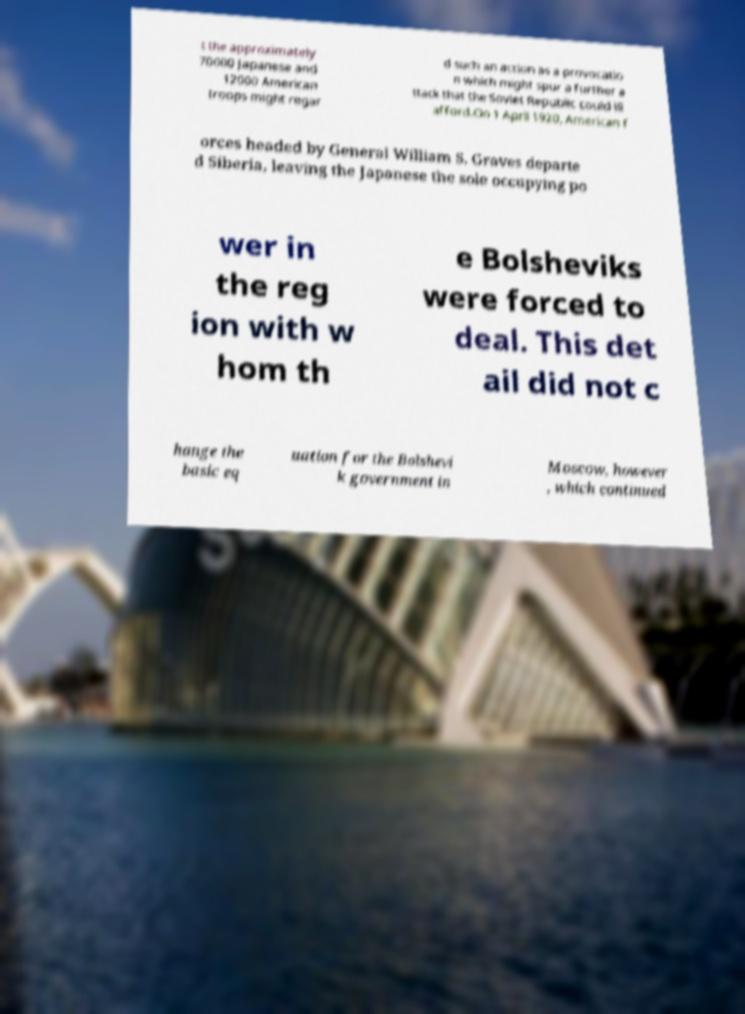For documentation purposes, I need the text within this image transcribed. Could you provide that? t the approximately 70000 Japanese and 12000 American troops might regar d such an action as a provocatio n which might spur a further a ttack that the Soviet Republic could ill afford.On 1 April 1920, American f orces headed by General William S. Graves departe d Siberia, leaving the Japanese the sole occupying po wer in the reg ion with w hom th e Bolsheviks were forced to deal. This det ail did not c hange the basic eq uation for the Bolshevi k government in Moscow, however , which continued 